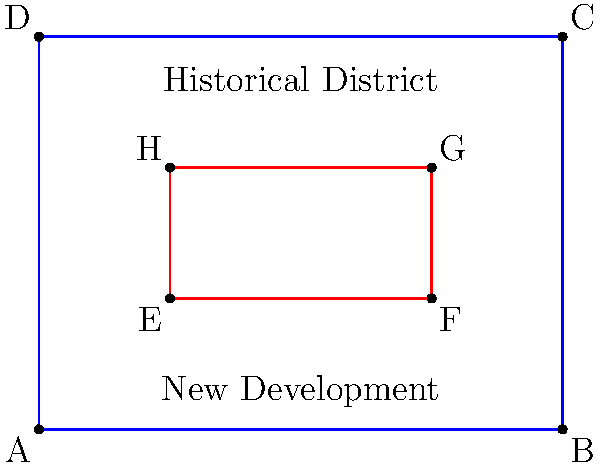The city council is planning a new development project within the historical district. The historical district is represented by rectangle ABCD, and the proposed new development area is represented by rectangle EFGH. Both rectangles' sides are parallel to the coordinate axes. Given that A(0,0), B(8,0), E(2,2), and F(6,2), calculate the area of overlap between the historical district and the new development area. To solve this problem, we'll follow these steps:

1) First, we need to determine the coordinates of all points:
   A(0,0), B(8,0), C(8,6), D(0,6)
   E(2,2), F(6,2), G(6,4), H(2,4)

2) The overlap area is a rectangle itself, with corners at E(2,2) and G(6,4).

3) To calculate the area of this overlap rectangle, we need its width and height:
   Width = $6 - 2 = 4$
   Height = $4 - 2 = 2$

4) The area of a rectangle is given by the formula:
   $$ \text{Area} = \text{width} \times \text{height} $$

5) Substituting our values:
   $$ \text{Area} = 4 \times 2 = 8 $$

Therefore, the area of overlap between the historical district and the new development area is 8 square units.
Answer: 8 square units 